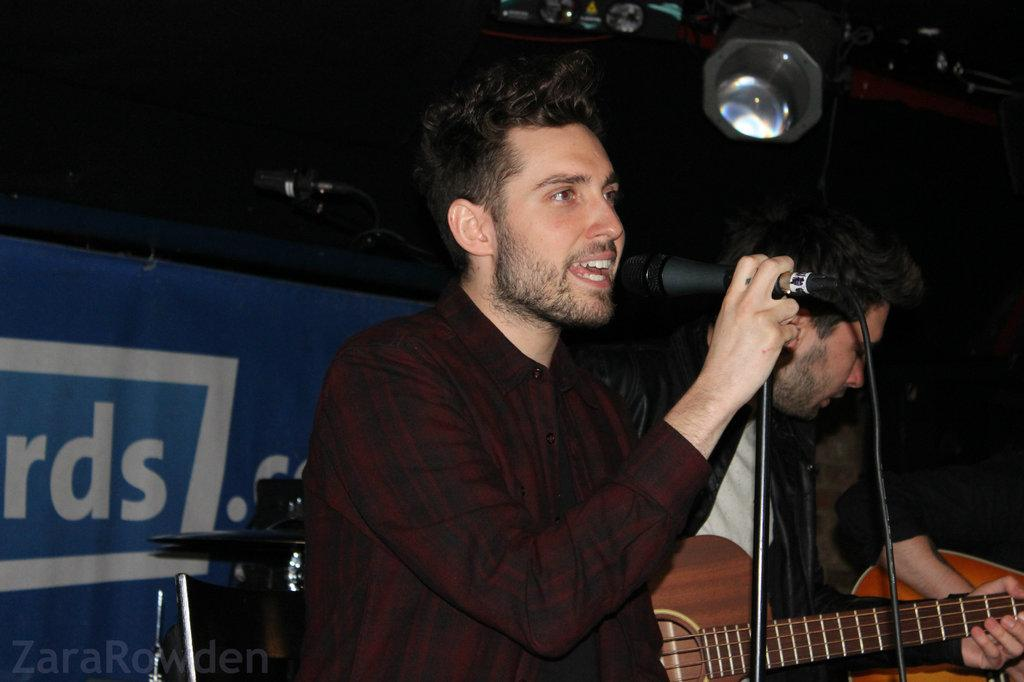How many people are in the image? There are two persons in the image. What is one of the persons holding? One of the persons is holding a mic. What type of scarecrow is present in the image? There is no scarecrow present in the image. What appliance is being used by the person holding the mic? The provided facts do not mention any appliance being used by the person holding the mic. 